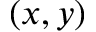<formula> <loc_0><loc_0><loc_500><loc_500>( x , y )</formula> 